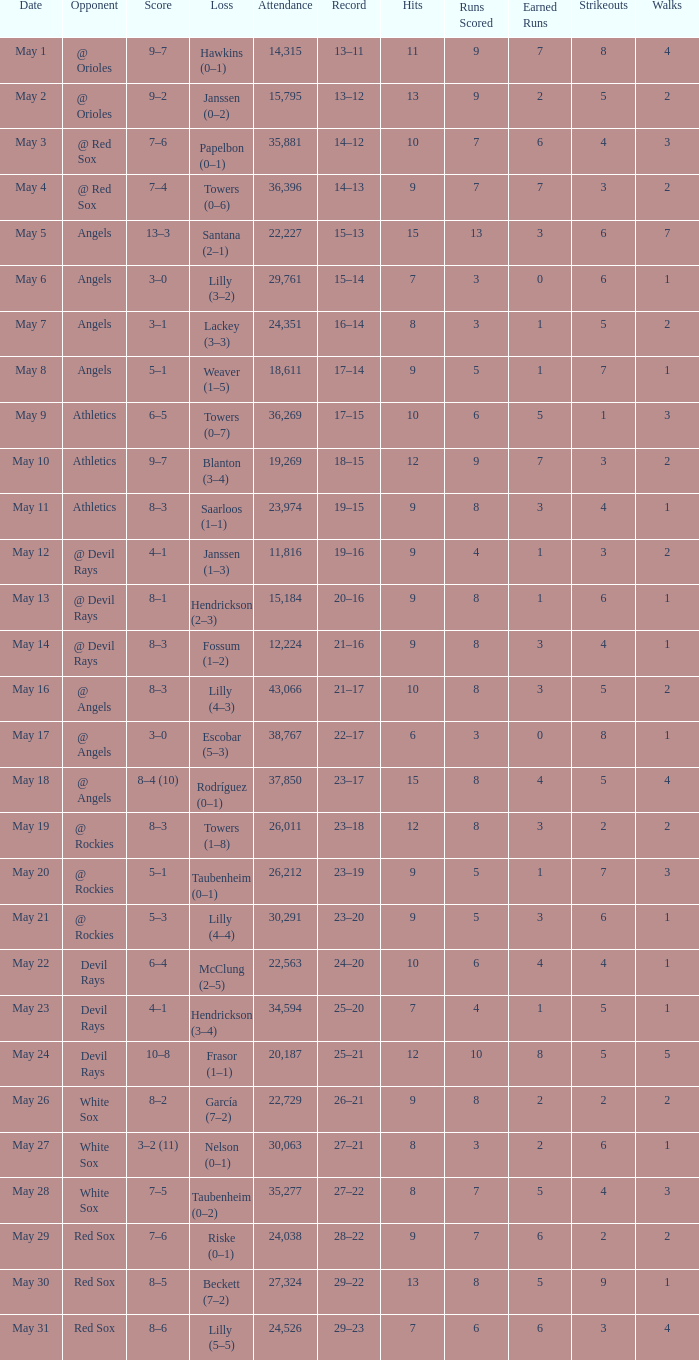What was the average attendance for games with a loss of papelbon (0–1)? 35881.0. 